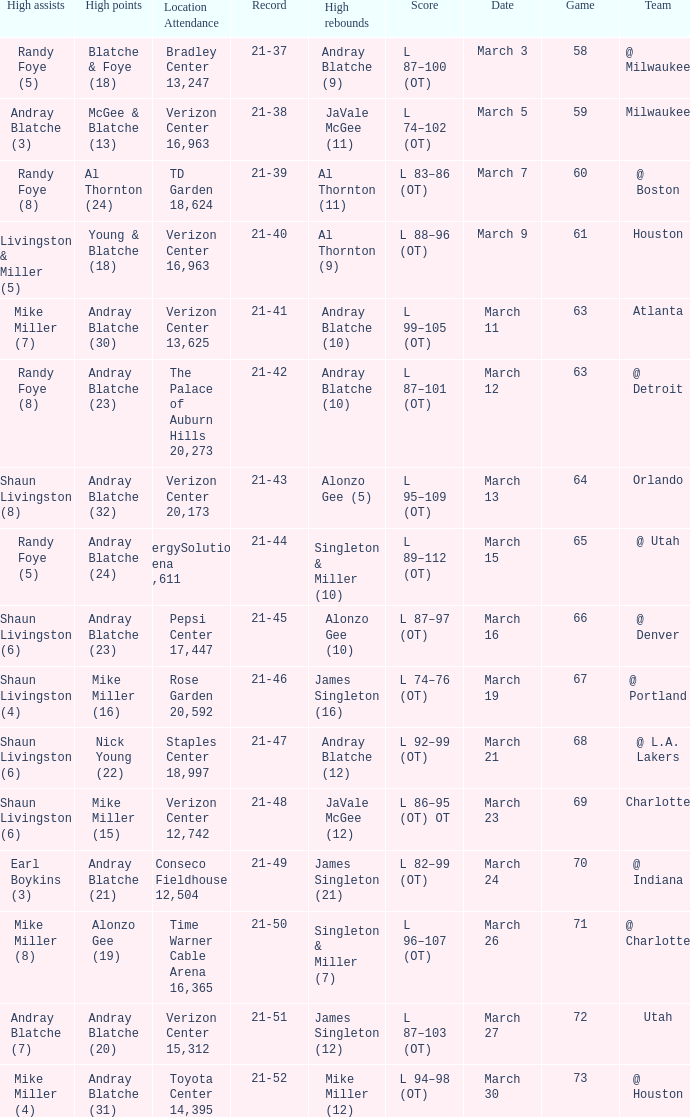On what date was the attendance at TD Garden 18,624? March 7. 